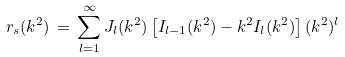<formula> <loc_0><loc_0><loc_500><loc_500>r _ { s } ( k ^ { 2 } ) \, = \, \sum _ { l = 1 } ^ { \infty } J _ { l } ( k ^ { 2 } ) \left [ I _ { l - 1 } ( k ^ { 2 } ) - k ^ { 2 } I _ { l } ( k ^ { 2 } ) \right ] ( k ^ { 2 } ) ^ { l }</formula> 